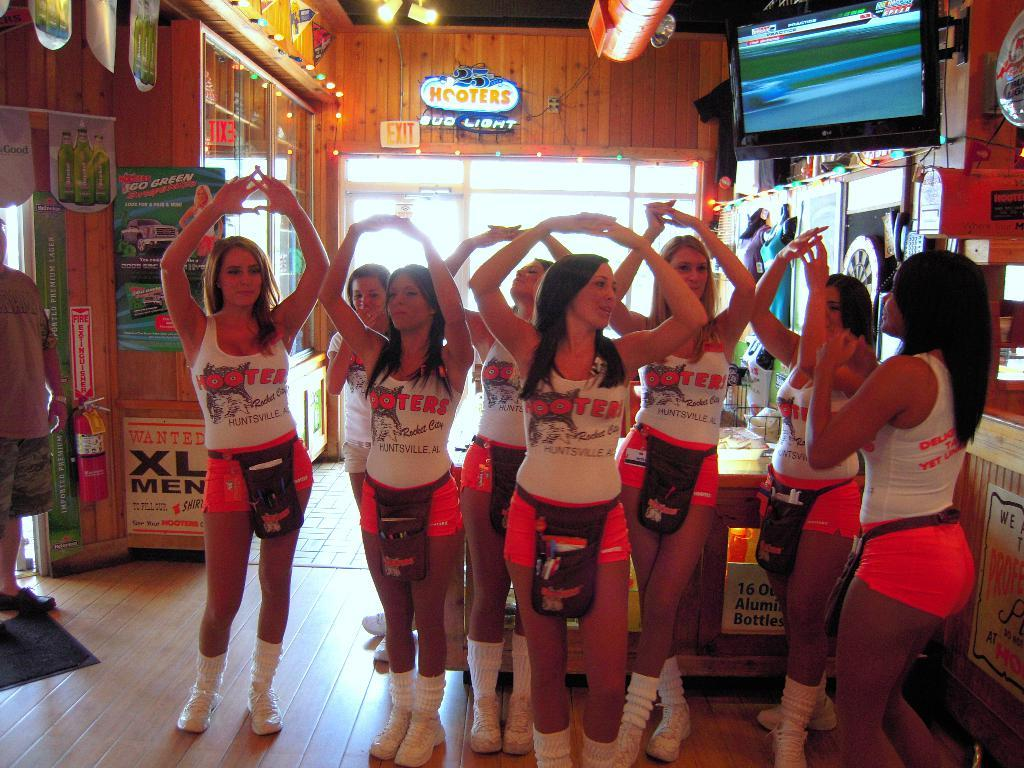<image>
Create a compact narrative representing the image presented. Group of Hooters girls standing together inside a room. 